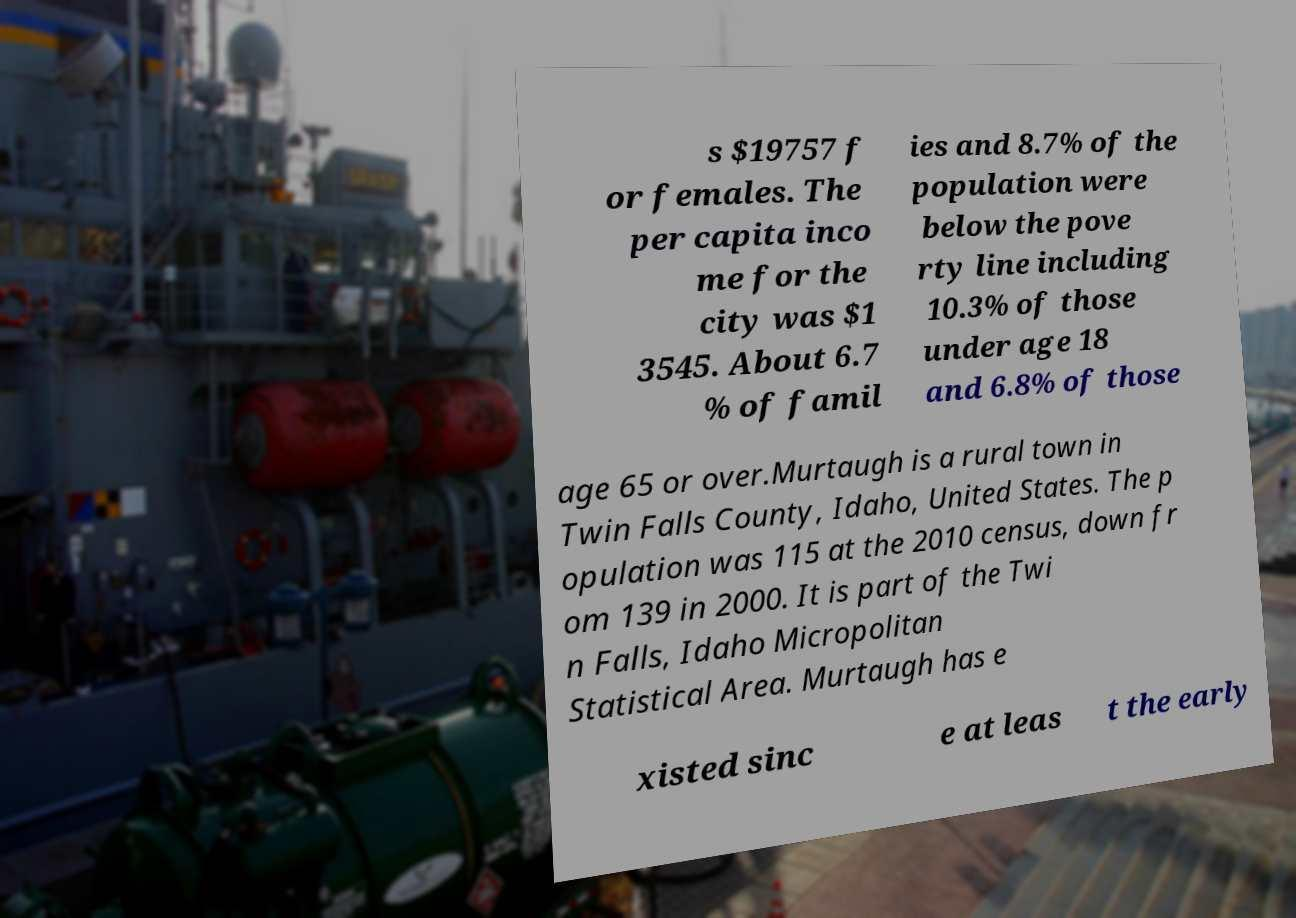What messages or text are displayed in this image? I need them in a readable, typed format. s $19757 f or females. The per capita inco me for the city was $1 3545. About 6.7 % of famil ies and 8.7% of the population were below the pove rty line including 10.3% of those under age 18 and 6.8% of those age 65 or over.Murtaugh is a rural town in Twin Falls County, Idaho, United States. The p opulation was 115 at the 2010 census, down fr om 139 in 2000. It is part of the Twi n Falls, Idaho Micropolitan Statistical Area. Murtaugh has e xisted sinc e at leas t the early 